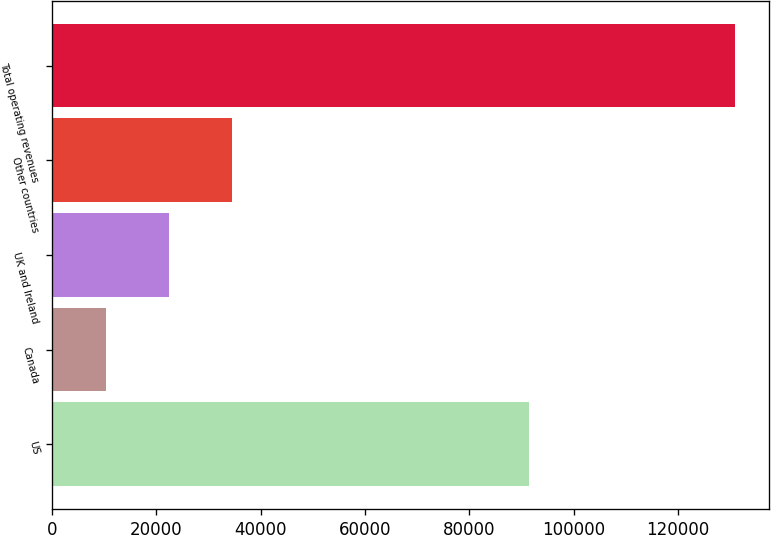Convert chart to OTSL. <chart><loc_0><loc_0><loc_500><loc_500><bar_chart><fcel>US<fcel>Canada<fcel>UK and Ireland<fcel>Other countries<fcel>Total operating revenues<nl><fcel>91499<fcel>10410<fcel>22453.4<fcel>34496.8<fcel>130844<nl></chart> 